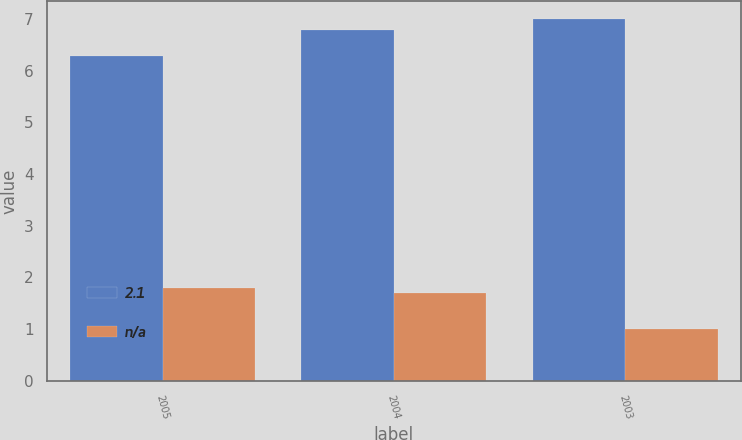Convert chart. <chart><loc_0><loc_0><loc_500><loc_500><stacked_bar_chart><ecel><fcel>2005<fcel>2004<fcel>2003<nl><fcel>2.1<fcel>6.29<fcel>6.78<fcel>6.99<nl><fcel>nan<fcel>1.8<fcel>1.7<fcel>1<nl></chart> 